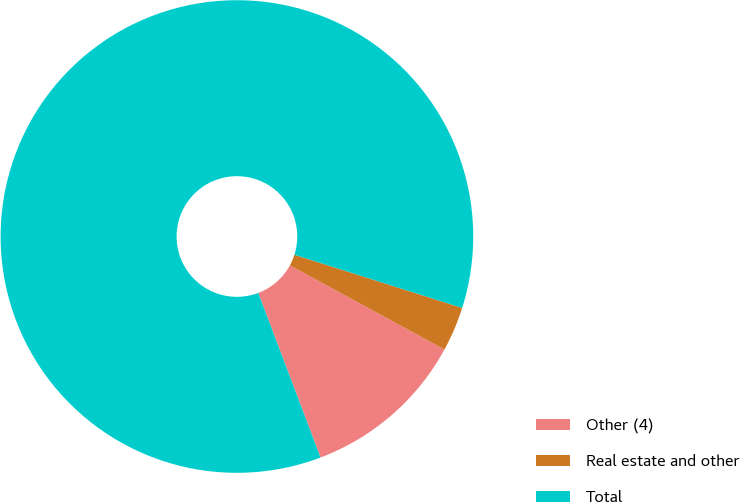<chart> <loc_0><loc_0><loc_500><loc_500><pie_chart><fcel>Other (4)<fcel>Real estate and other<fcel>Total<nl><fcel>11.31%<fcel>3.05%<fcel>85.64%<nl></chart> 